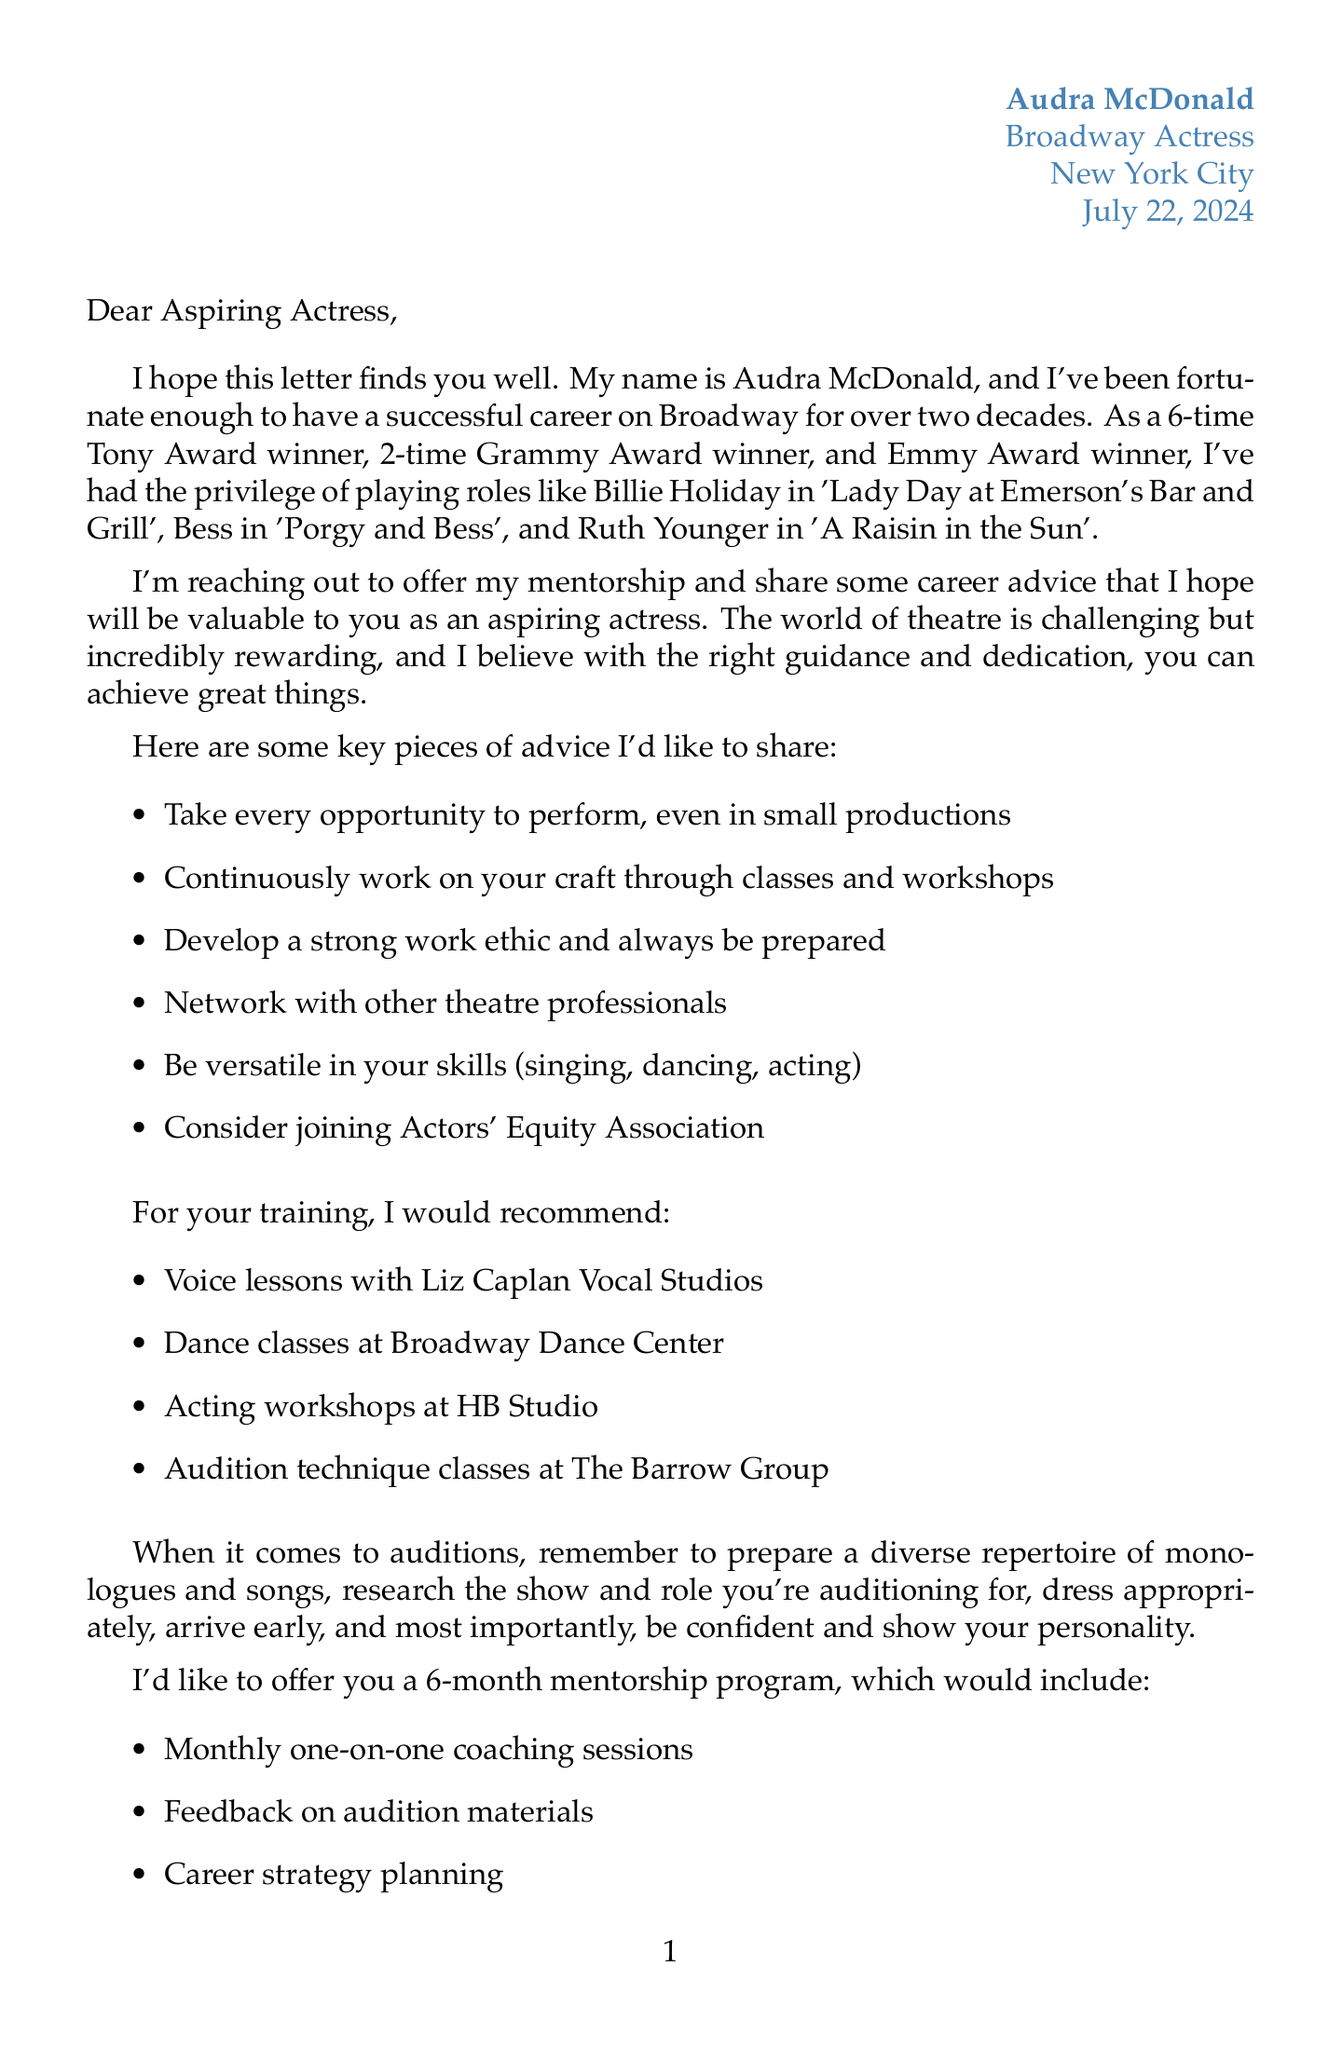What is Audra McDonald's profession? Audra McDonald mentions her profession as a Broadway actress in the introduction.
Answer: Broadway actress How many Tony Awards has Audra won? The letter states that Audra McDonald is a 6-time Tony Award winner.
Answer: 6 What is one of the notable roles mentioned? The letter lists several notable roles, and "Billie Holiday in 'Lady Day at Emerson's Bar and Grill'" is one of them.
Answer: Billie Holiday in 'Lady Day at Emerson's Bar and Grill' How long is the mentorship program Audra is offering? The letter specifies that the mentorship program is for a duration of 6 months.
Answer: 6 months Name a training recommendation for voice lessons. The letter recommends voice lessons at Liz Caplan Vocal Studios for training.
Answer: Liz Caplan Vocal Studios What is one of the challenges mentioned in the document? The letter lists challenges in the industry, including "Dealing with rejection."
Answer: Dealing with rejection What type of resource is 'A Life in Parts'? The letter categorizes 'A Life in Parts' as a book that is recommended as a resource.
Answer: Book What kind of sessions will be included in the mentorship? The letter states that the mentorship includes monthly one-on-one coaching sessions.
Answer: Monthly one-on-one coaching sessions Which organization is suggested for further support? The letter mentions "The Actors Fund" as one of the organizations for further support.
Answer: The Actors Fund 